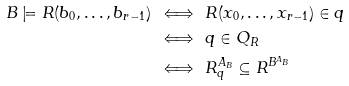Convert formula to latex. <formula><loc_0><loc_0><loc_500><loc_500>B \models R ( b _ { 0 } , \dots , b _ { r - 1 } ) \, & \iff \, R ( x _ { 0 } , \dots , x _ { r - 1 } ) \in q \\ & \iff \, q \in Q _ { R } \\ & \iff \, R _ { q } ^ { A _ { B } } \subseteq R ^ { B ^ { A _ { B } } } \\</formula> 